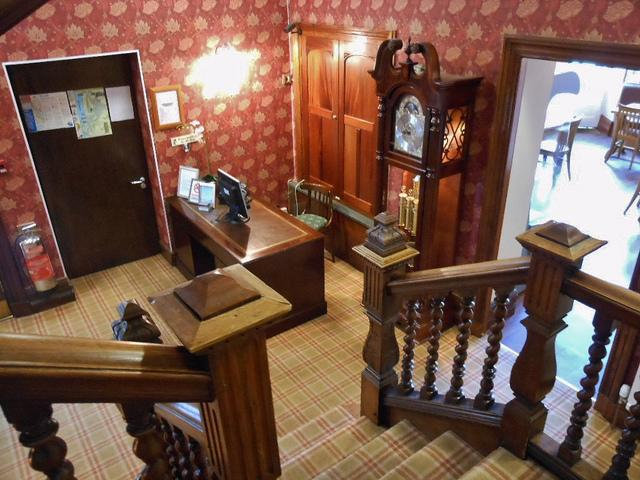What is attached to the brown door?

Choices:
A) garbage bag
B) pastries
C) cross
D) papers papers 